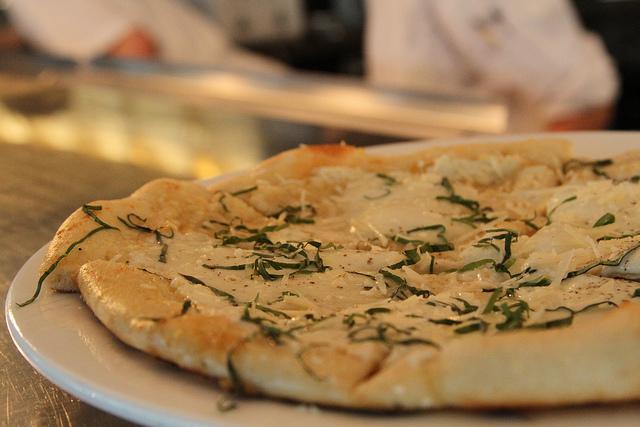What is on the plate?
Keep it brief. Pizza. What is the pizza for?
Short answer required. Eating. Is the plate made of wood?
Answer briefly. No. Is this food ready to eat?
Quick response, please. Yes. What is the green in the meal?
Concise answer only. Basil. Is this a healthy or unhealthy meal for one?
Quick response, please. Unhealthy. What is the pizza sitting in?
Concise answer only. Plate. 